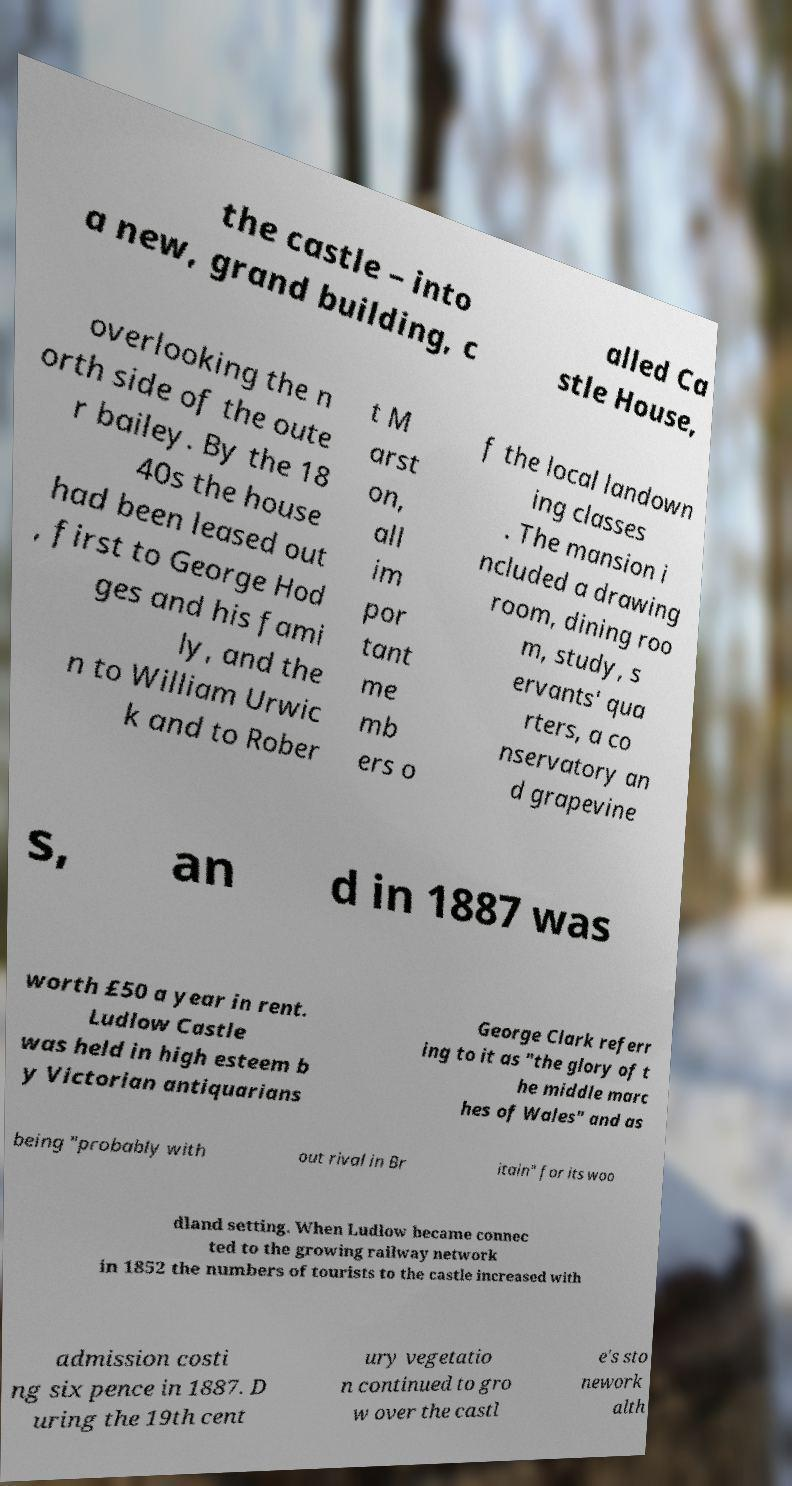What messages or text are displayed in this image? I need them in a readable, typed format. the castle – into a new, grand building, c alled Ca stle House, overlooking the n orth side of the oute r bailey. By the 18 40s the house had been leased out , first to George Hod ges and his fami ly, and the n to William Urwic k and to Rober t M arst on, all im por tant me mb ers o f the local landown ing classes . The mansion i ncluded a drawing room, dining roo m, study, s ervants' qua rters, a co nservatory an d grapevine s, an d in 1887 was worth £50 a year in rent. Ludlow Castle was held in high esteem b y Victorian antiquarians George Clark referr ing to it as "the glory of t he middle marc hes of Wales" and as being "probably with out rival in Br itain" for its woo dland setting. When Ludlow became connec ted to the growing railway network in 1852 the numbers of tourists to the castle increased with admission costi ng six pence in 1887. D uring the 19th cent ury vegetatio n continued to gro w over the castl e's sto nework alth 